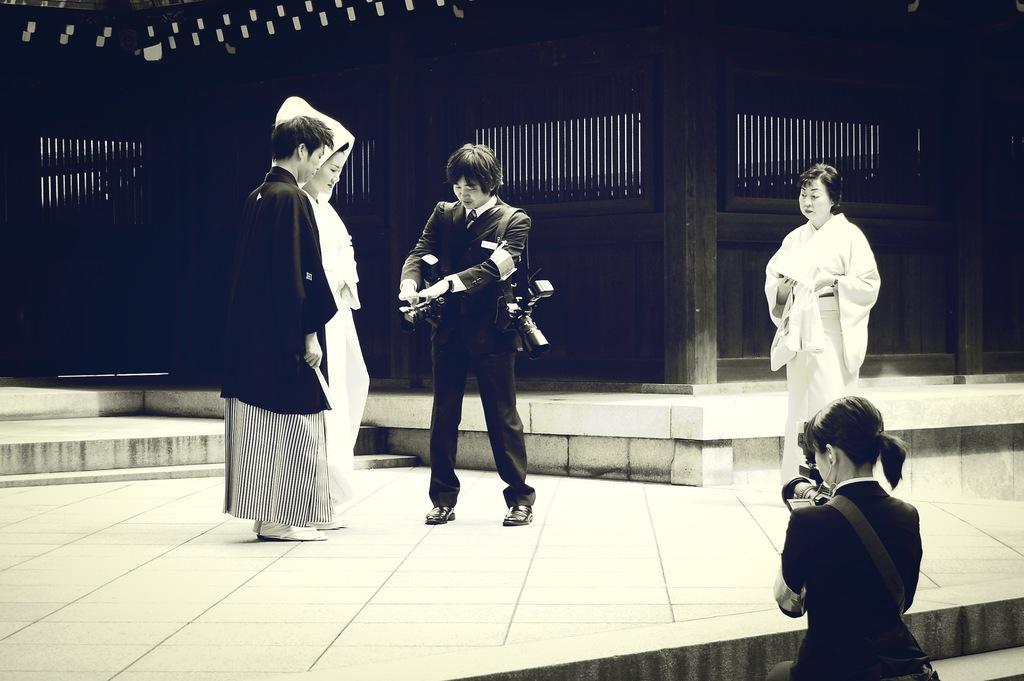How would you summarize this image in a sentence or two? In the background we can see the wall and it is completely dark. In this picture we can see people standing on the floor. We can see a man holding an object in his hand and we can see a camera. In the bottom right corner of the picture we can see a woman holding a camera and recording. 